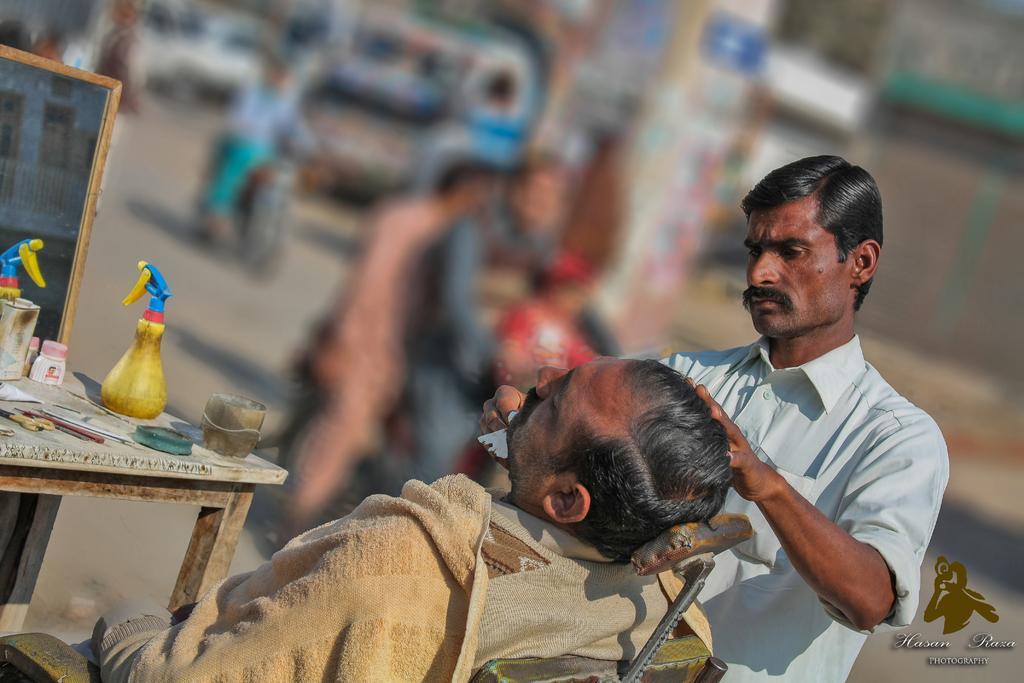Describe this image in one or two sentences. In this image, we can see a man shaving to another man whose is sitting on the chair and we can see some objects placed on the table and there is a board. In the background, there are some people and vehicles on the road. At the bottom, there is some text written. 